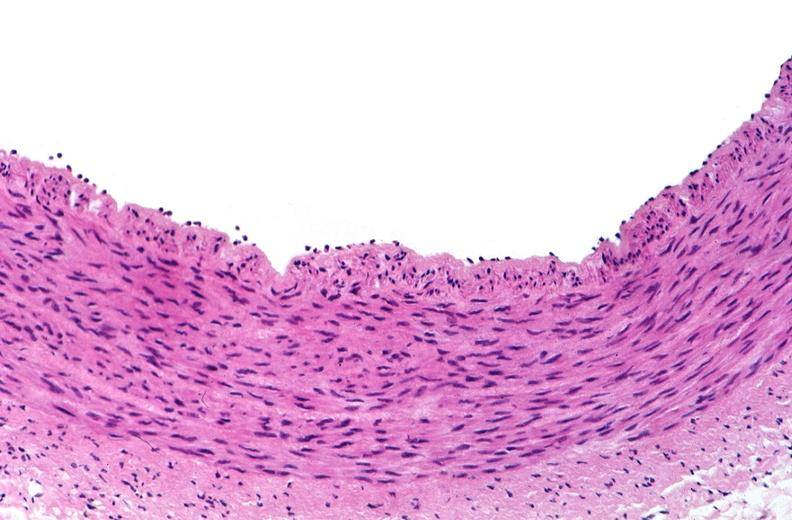s cardiovascular present?
Answer the question using a single word or phrase. Yes 